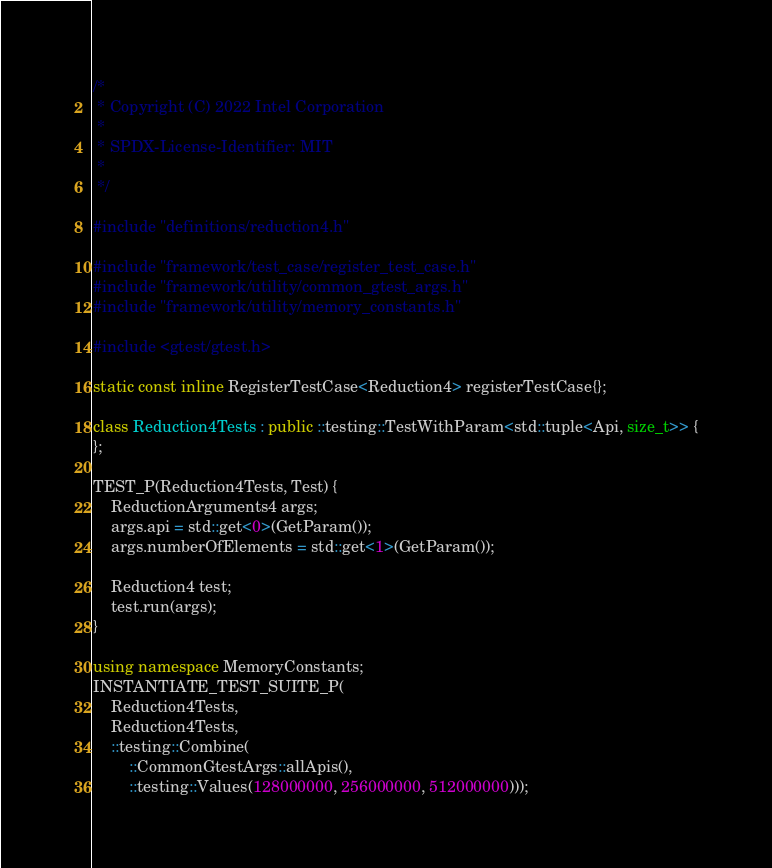<code> <loc_0><loc_0><loc_500><loc_500><_C++_>/*
 * Copyright (C) 2022 Intel Corporation
 *
 * SPDX-License-Identifier: MIT
 *
 */

#include "definitions/reduction4.h"

#include "framework/test_case/register_test_case.h"
#include "framework/utility/common_gtest_args.h"
#include "framework/utility/memory_constants.h"

#include <gtest/gtest.h>

static const inline RegisterTestCase<Reduction4> registerTestCase{};

class Reduction4Tests : public ::testing::TestWithParam<std::tuple<Api, size_t>> {
};

TEST_P(Reduction4Tests, Test) {
    ReductionArguments4 args;
    args.api = std::get<0>(GetParam());
    args.numberOfElements = std::get<1>(GetParam());

    Reduction4 test;
    test.run(args);
}

using namespace MemoryConstants;
INSTANTIATE_TEST_SUITE_P(
    Reduction4Tests,
    Reduction4Tests,
    ::testing::Combine(
        ::CommonGtestArgs::allApis(),
        ::testing::Values(128000000, 256000000, 512000000)));
</code> 